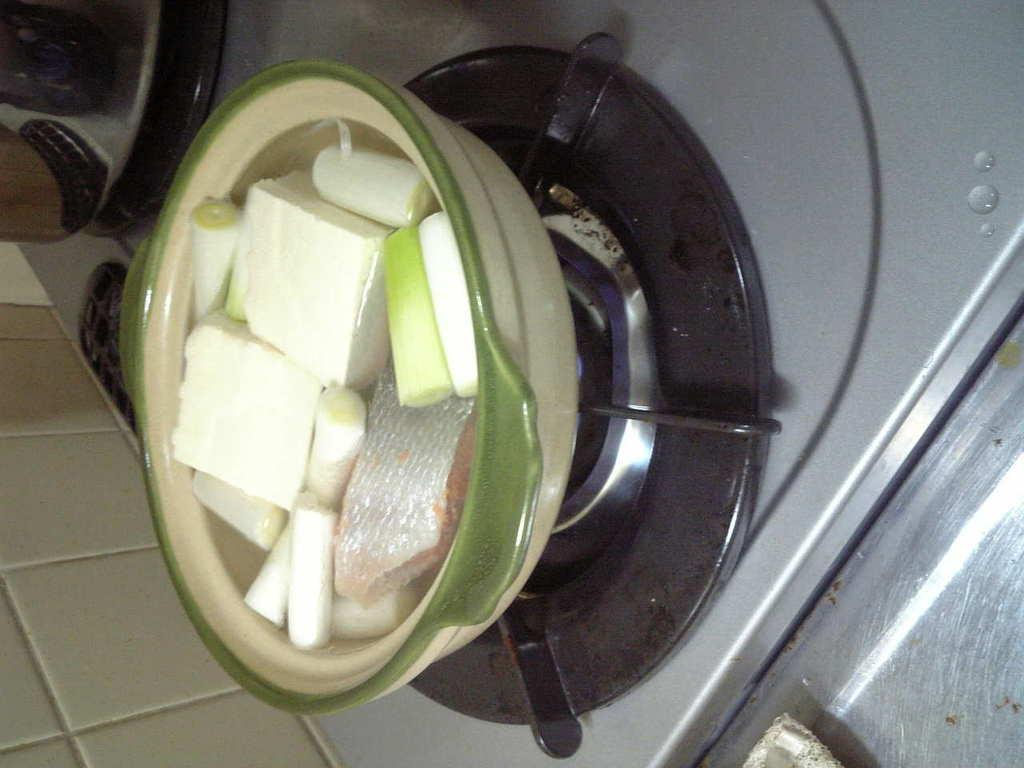What type of appliance is present in the image? There is a stove in the image. Where is the stove located? The stove is placed over a surface. What is on top of the stove? There is a bowl on the stove. What is in the bowl on the stove? The bowl contains water and vegetables. What songs are being sung by the vegetables in the bowl? There are no songs being sung by the vegetables in the bowl, as vegetables do not have the ability to sing. 